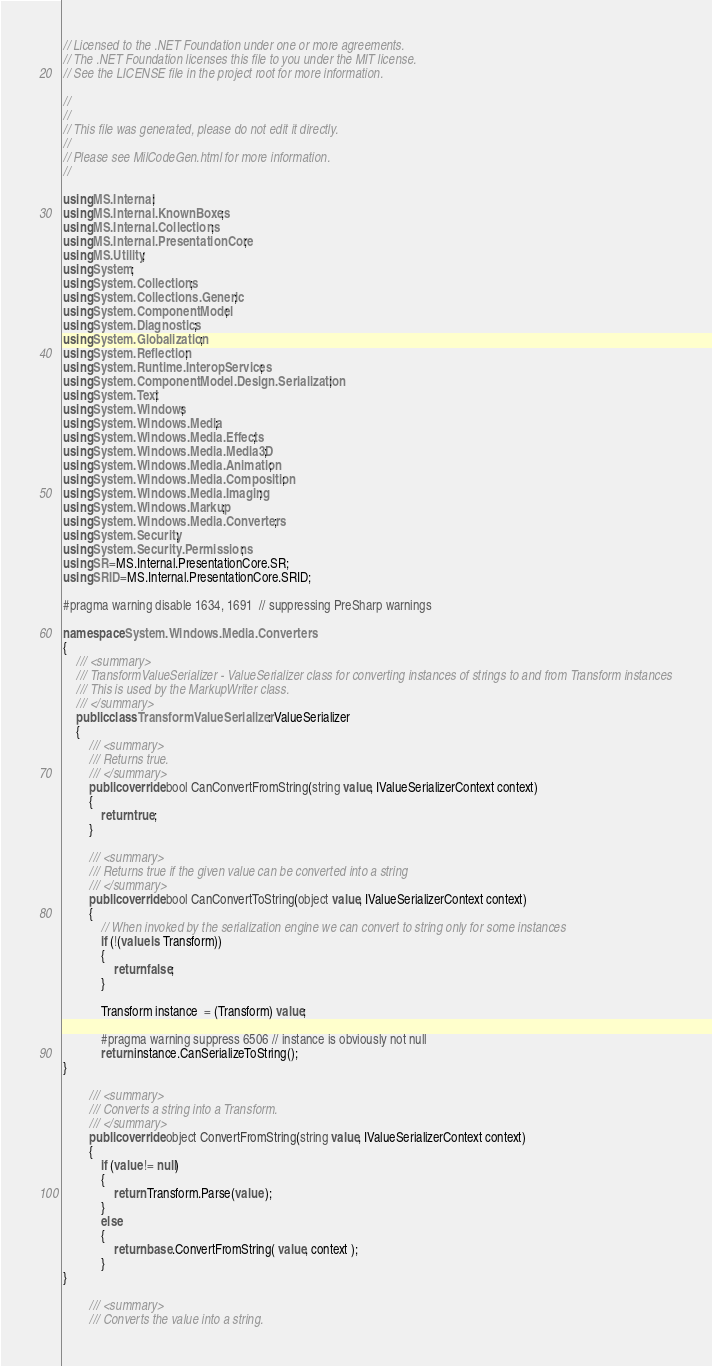Convert code to text. <code><loc_0><loc_0><loc_500><loc_500><_C#_>// Licensed to the .NET Foundation under one or more agreements.
// The .NET Foundation licenses this file to you under the MIT license.
// See the LICENSE file in the project root for more information.

//
//
// This file was generated, please do not edit it directly.
//
// Please see MilCodeGen.html for more information.
//

using MS.Internal;
using MS.Internal.KnownBoxes;
using MS.Internal.Collections;
using MS.Internal.PresentationCore;
using MS.Utility;
using System;
using System.Collections;
using System.Collections.Generic;
using System.ComponentModel;
using System.Diagnostics;
using System.Globalization;
using System.Reflection;
using System.Runtime.InteropServices;
using System.ComponentModel.Design.Serialization;
using System.Text;
using System.Windows;
using System.Windows.Media;
using System.Windows.Media.Effects;
using System.Windows.Media.Media3D;
using System.Windows.Media.Animation;
using System.Windows.Media.Composition;
using System.Windows.Media.Imaging;
using System.Windows.Markup;
using System.Windows.Media.Converters;
using System.Security;
using System.Security.Permissions;
using SR=MS.Internal.PresentationCore.SR;
using SRID=MS.Internal.PresentationCore.SRID;

#pragma warning disable 1634, 1691  // suppressing PreSharp warnings

namespace System.Windows.Media.Converters
{
    /// <summary>
    /// TransformValueSerializer - ValueSerializer class for converting instances of strings to and from Transform instances
    /// This is used by the MarkupWriter class.
    /// </summary>
    public class TransformValueSerializer : ValueSerializer 
    {
        /// <summary>
        /// Returns true.
        /// </summary>
        public override bool CanConvertFromString(string value, IValueSerializerContext context)
        {
            return true;
        }

        /// <summary>
        /// Returns true if the given value can be converted into a string
        /// </summary>
        public override bool CanConvertToString(object value, IValueSerializerContext context)
        {
            // When invoked by the serialization engine we can convert to string only for some instances
            if (!(value is Transform))
            {
                return false;
            }

            Transform instance  = (Transform) value;

            #pragma warning suppress 6506 // instance is obviously not null
            return instance.CanSerializeToString();
}

        /// <summary>
        /// Converts a string into a Transform.
        /// </summary>
        public override object ConvertFromString(string value, IValueSerializerContext context)
        {
            if (value != null)
            {
                return Transform.Parse(value );
            }
            else
            {
                return base.ConvertFromString( value, context );
            }
}

        /// <summary>
        /// Converts the value into a string.</code> 